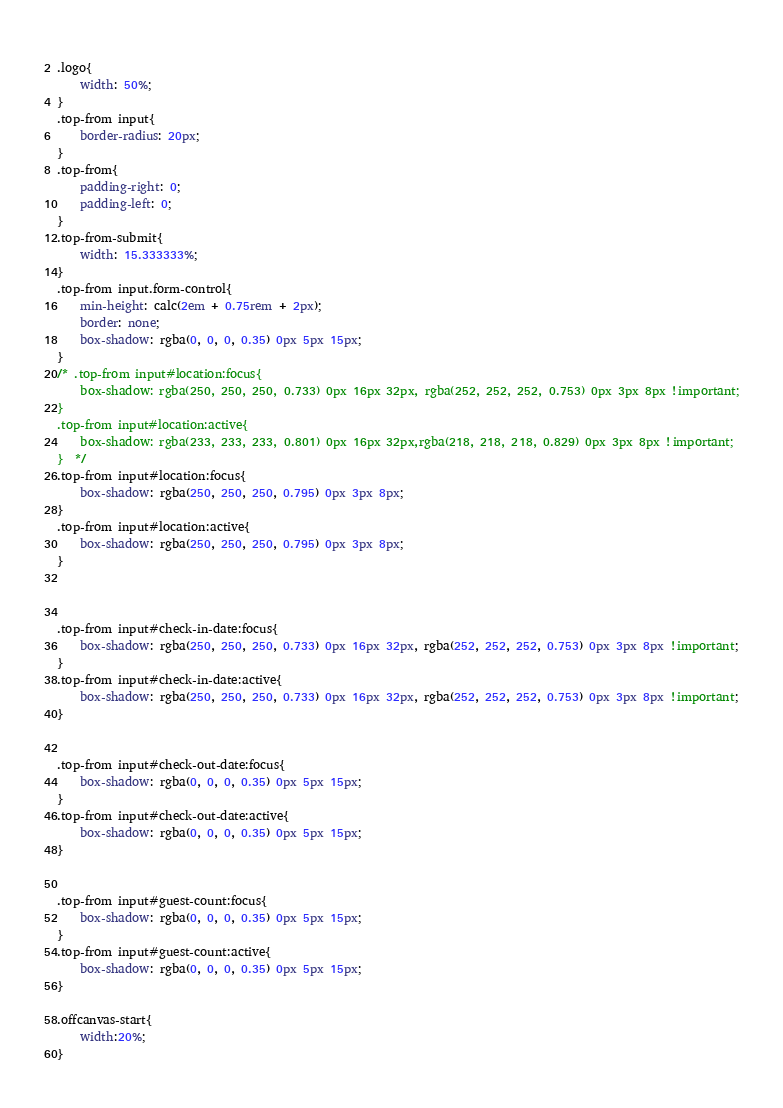Convert code to text. <code><loc_0><loc_0><loc_500><loc_500><_CSS_> 
.logo{
    width: 50%;
}
.top-from input{
    border-radius: 20px;
}
.top-from{ 
    padding-right: 0;
    padding-left: 0;
}
.top-from-submit{
    width: 15.333333%;
}
.top-from input.form-control{
    min-height: calc(2em + 0.75rem + 2px); 
    border: none; 
    box-shadow: rgba(0, 0, 0, 0.35) 0px 5px 15px;
}
/* .top-from input#location:focus{
    box-shadow: rgba(250, 250, 250, 0.733) 0px 16px 32px, rgba(252, 252, 252, 0.753) 0px 3px 8px !important;
}
.top-from input#location:active{
    box-shadow: rgba(233, 233, 233, 0.801) 0px 16px 32px,rgba(218, 218, 218, 0.829) 0px 3px 8px !important;
}  */
.top-from input#location:focus{
    box-shadow: rgba(250, 250, 250, 0.795) 0px 3px 8px;
}
.top-from input#location:active{
    box-shadow: rgba(250, 250, 250, 0.795) 0px 3px 8px;
} 
 


.top-from input#check-in-date:focus{
    box-shadow: rgba(250, 250, 250, 0.733) 0px 16px 32px, rgba(252, 252, 252, 0.753) 0px 3px 8px !important;
}
.top-from input#check-in-date:active{
    box-shadow: rgba(250, 250, 250, 0.733) 0px 16px 32px, rgba(252, 252, 252, 0.753) 0px 3px 8px !important;
} 


.top-from input#check-out-date:focus{
    box-shadow: rgba(0, 0, 0, 0.35) 0px 5px 15px;
}
.top-from input#check-out-date:active{
    box-shadow: rgba(0, 0, 0, 0.35) 0px 5px 15px;
} 


.top-from input#guest-count:focus{
    box-shadow: rgba(0, 0, 0, 0.35) 0px 5px 15px;
}
.top-from input#guest-count:active{
    box-shadow: rgba(0, 0, 0, 0.35) 0px 5px 15px;
} 

.offcanvas-start{
    width:20%;
}

</code> 